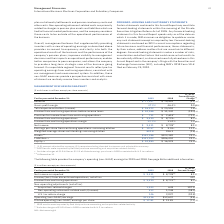According to International Business Machines's financial document, In 2018, net income includes what additional charges? Includes charges of $2.0 billion in 2018 associated with U.S. tax reform.. The document states: "se accounting and acquisition-related activity. ** Includes charges of $2.0 billion in 2018 associated with U.S. tax reform. NM—Not meaningful..." Also, In 2019, results were impacted by which activity? 2019 results were impacted by Red Hat purchase accounting and acquisition-related activity.. The document states: "divested businesses and adjusted for currency. ** 2019 results were impacted by Red Hat purchase accounting and acquisition-related activity. + Includ..." Also, What was the U.S. tax reform charge in 2019? According to the financial document, 146 (in millions). The relevant text states: "U.S. tax reform charge 146 2,037 (92.8)..." Also, can you calculate: What was the increase / (decrease) in Net income from 2018 to 2019? Based on the calculation: 9,431 - 8,728, the result is 703 (in millions). This is based on the information: "Net income $ 9,431 $ 8,728 + 8.1% Net income $ 9,431 $ 8,728 + 8.1%..." The key data points involved are: 8,728, 9,431. Also, can you calculate: What was the increase / (decrease) in Income from continuing operations from 2018 to 2019? Based on the calculation: 9,435 - 8,723, the result is 712 (in millions). This is based on the information: "Income from continuing operations $ 9,435 $ 8,723 + 8.2% Income from continuing operations $ 9,435 $ 8,723 + 8.2%..." The key data points involved are: 8,723, 9,435. Also, can you calculate: What was the increase / (decrease) in Operating (non-GAAP) earnings from continuing operations from 2018 to 2019? Based on the calculation: 11,436 - 12,657, the result is -1221 (in millions). This is based on the information: "Operating (non-GAAP) earnings $11,436 $12,657 (9.6)% Operating (non-GAAP) earnings $11,436 $12,657 (9.6)%..." The key data points involved are: 11,436, 12,657. 